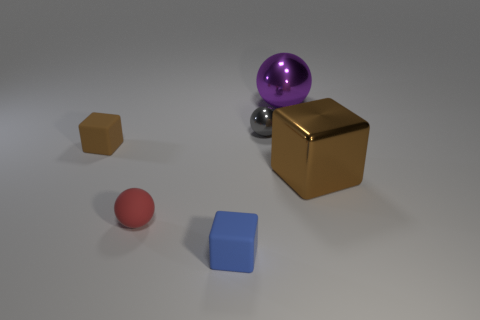Add 3 brown rubber things. How many objects exist? 9 Add 3 purple metal things. How many purple metal things exist? 4 Subtract 1 blue cubes. How many objects are left? 5 Subtract all matte things. Subtract all large metal blocks. How many objects are left? 2 Add 4 blue rubber cubes. How many blue rubber cubes are left? 5 